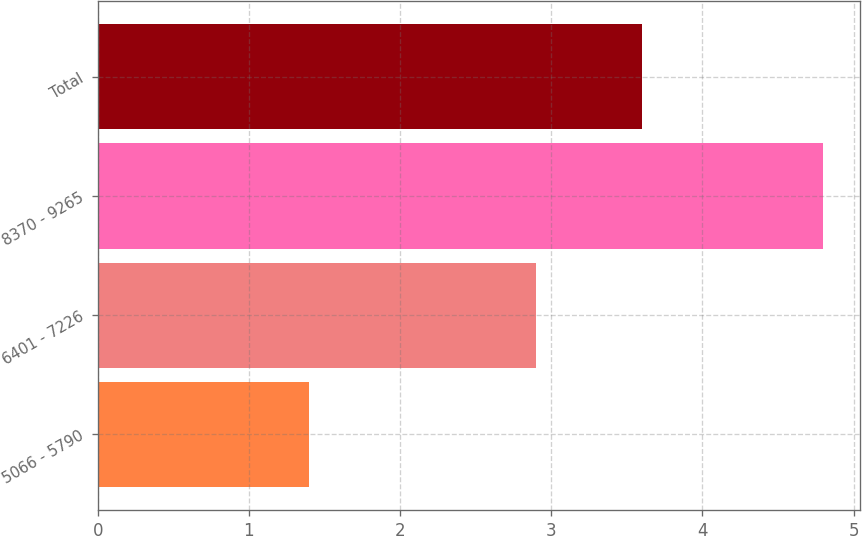<chart> <loc_0><loc_0><loc_500><loc_500><bar_chart><fcel>5066 - 5790<fcel>6401 - 7226<fcel>8370 - 9265<fcel>Total<nl><fcel>1.4<fcel>2.9<fcel>4.8<fcel>3.6<nl></chart> 